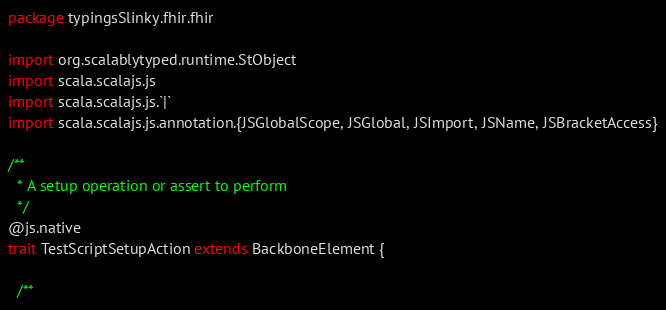<code> <loc_0><loc_0><loc_500><loc_500><_Scala_>package typingsSlinky.fhir.fhir

import org.scalablytyped.runtime.StObject
import scala.scalajs.js
import scala.scalajs.js.`|`
import scala.scalajs.js.annotation.{JSGlobalScope, JSGlobal, JSImport, JSName, JSBracketAccess}

/**
  * A setup operation or assert to perform
  */
@js.native
trait TestScriptSetupAction extends BackboneElement {
  
  /**</code> 